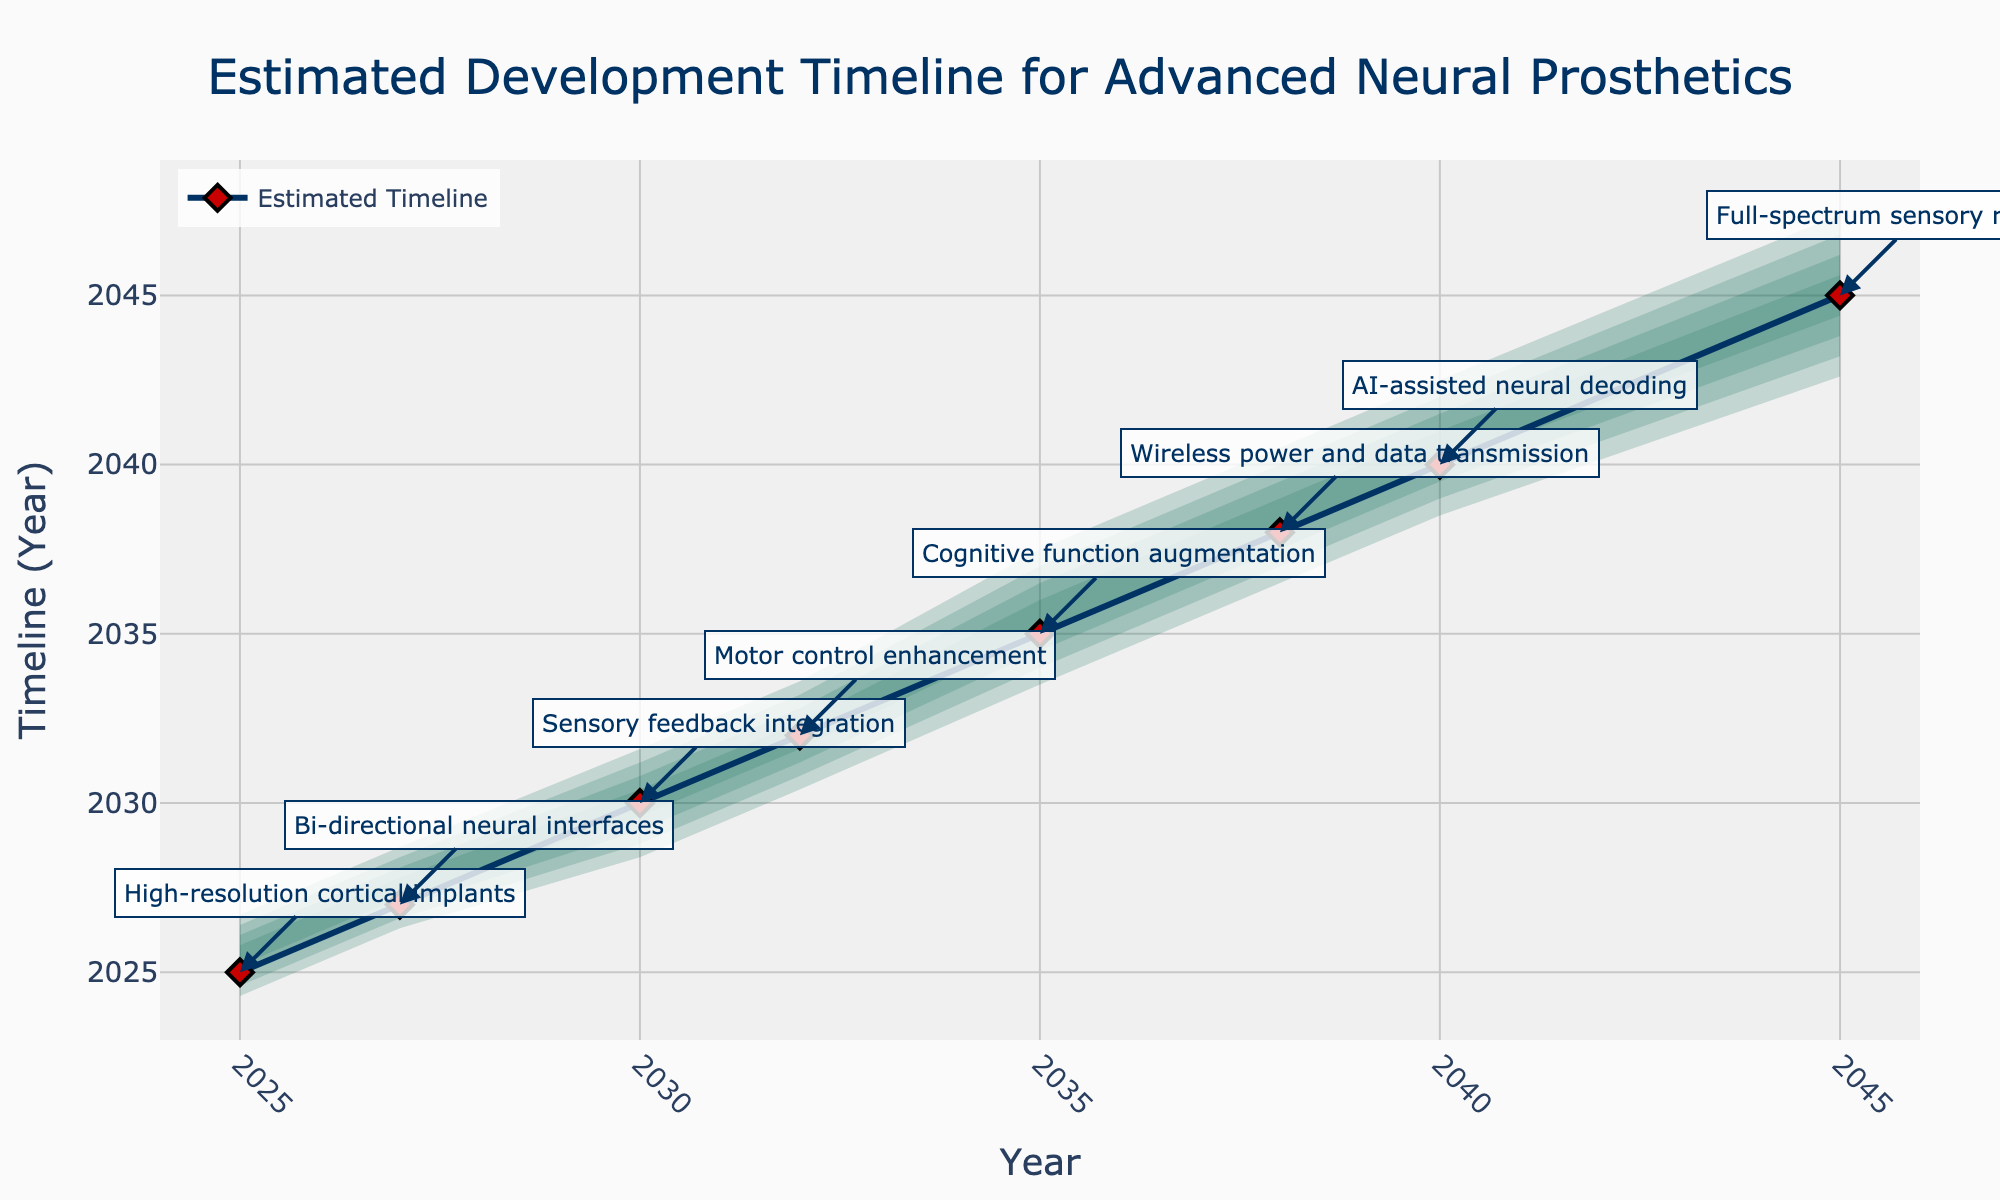What is the title of the chart? The title is located at the top center of the chart. It gives an overview of what the chart represents. By looking at the chart, we can see the text says "Estimated Development Timeline for Advanced Neural Prosthetics".
Answer: Estimated Development Timeline for Advanced Neural Prosthetics Which milestone is estimated to be completed in 2030? To determine this, we can look at the marking positions along the central estimate line for each year. The milestone associated with 2030 has a label pointing to it, which is "Sensory feedback integration".
Answer: Sensory feedback integration Between which years does "AI-assisted neural decoding" have its uncertainty range? Find the milestone "AI-assisted neural decoding" on the chart and check the shaded area which represents its uncertainty range. The range spans from 2038 to 2043.
Answer: 2038 to 2043 What is the estimated completion year for "Cognitive function augmentation"? Locate the "Cognitive function augmentation" annotation and check the central estimate line going through the chart. This milestone is estimated for 2035.
Answer: 2035 How many milestones are shown in the chart? Count the number of annotations or milestones listed in the chart. There are 8 milestones indicated on the chart.
Answer: 8 What is the earliest lower bound for any milestone? Observing the lower 10% bounds for each milestone in the chart, the earliest year is for "High-resolution cortical implants" at 2024.
Answer: 2024 Compare the uncertainty ranges of "Motor control enhancement" and "Wireless power and data transmission". Which has a shorter range? Examine the shaded areas for both milestones. "Motor control enhancement" ranges from 2030 to 2034 (4 years), while "Wireless power and data transmission" ranges from 2036 to 2041 (5 years). Thus, "Motor control enhancement" has a shorter range.
Answer: Motor control enhancement What is the difference between the upper 90% bound and the estimate for "Full-spectrum sensory restoration"? Locate the estimate and upper bound for "Full-spectrum sensory restoration". The estimate is 2045 and the upper bound is 2048. The difference is 2048 - 2045 = 3 years.
Answer: 3 years Which milestone is projected to be completed the latest according to the central estimate line? By checking the positioning of all milestones along the central estimate line, the latest projected completion is "Full-spectrum sensory restoration" in 2045.
Answer: Full-spectrum sensory restoration What is the average year for the upper 90% bounds of the milestones up to "Cognitive function augmentation"? The milestones up to "Cognitive function augmentation" are from 2025 to 2035. The upper 90% bounds are 2027, 2029, 2032, 2034, and 2038. Compute the average: (2027 + 2029 + 2032 + 2034 + 2038) / 5 = 2032.
Answer: 2032 